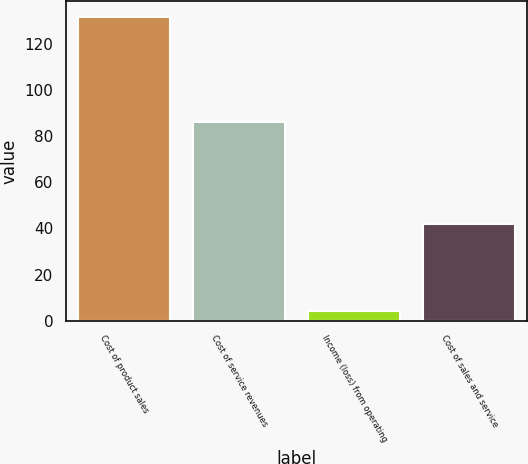Convert chart. <chart><loc_0><loc_0><loc_500><loc_500><bar_chart><fcel>Cost of product sales<fcel>Cost of service revenues<fcel>Income (loss) from operating<fcel>Cost of sales and service<nl><fcel>132<fcel>86<fcel>4<fcel>42<nl></chart> 